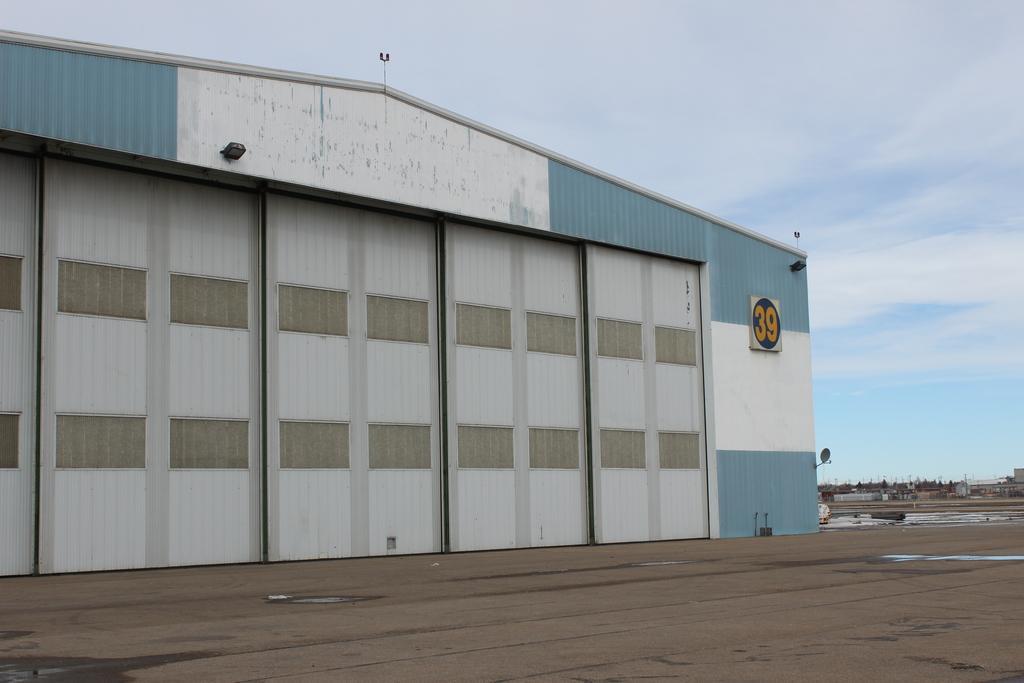How would you summarize this image in a sentence or two? In this image it looks like it is a Godown. At the top there is sky. At the bottom there is floor on which there is water. In the foreground there are asbestos sheets which are kept one beside the other. 